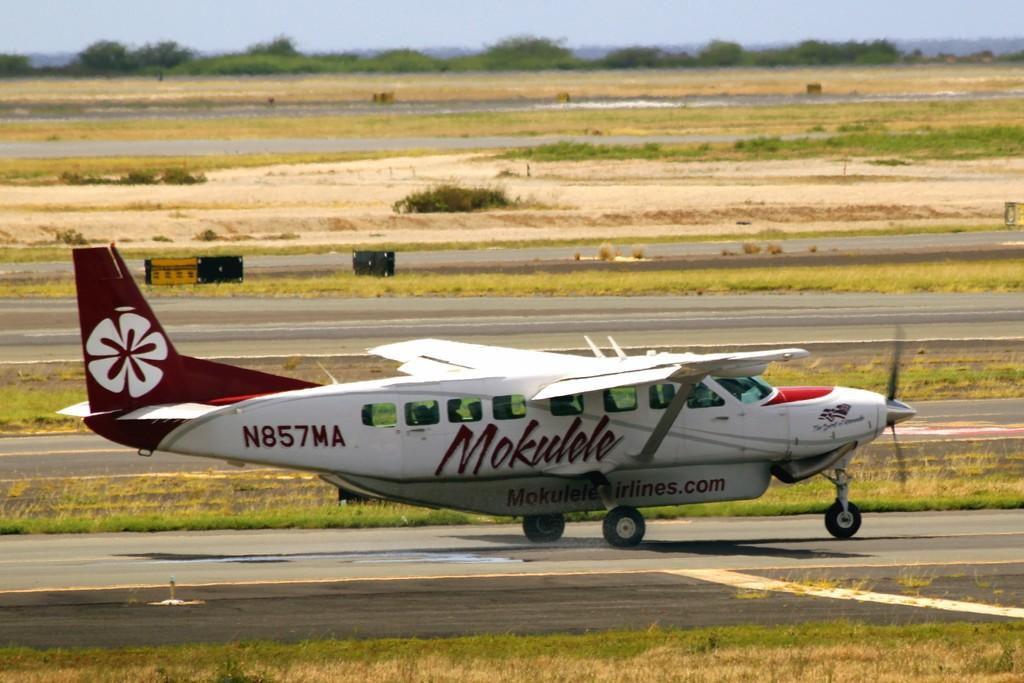What is the main subject of the image? The main subject of the image is an aircraft. What colors are used for the aircraft? The aircraft is in red and white color. What type of natural environment is visible in the image? There are trees and grass visible in the image. What is visible in the background of the image? The sky is visible in the image. What type of station can be seen in the image? There is no station present in the image; it features an aircraft in a natural environment. What flavor of eggnog is being served in the image? There is no eggnog present in the image. What thought is being expressed by the aircraft in the image? Aircrafts do not express thoughts, as they are inanimate objects. 